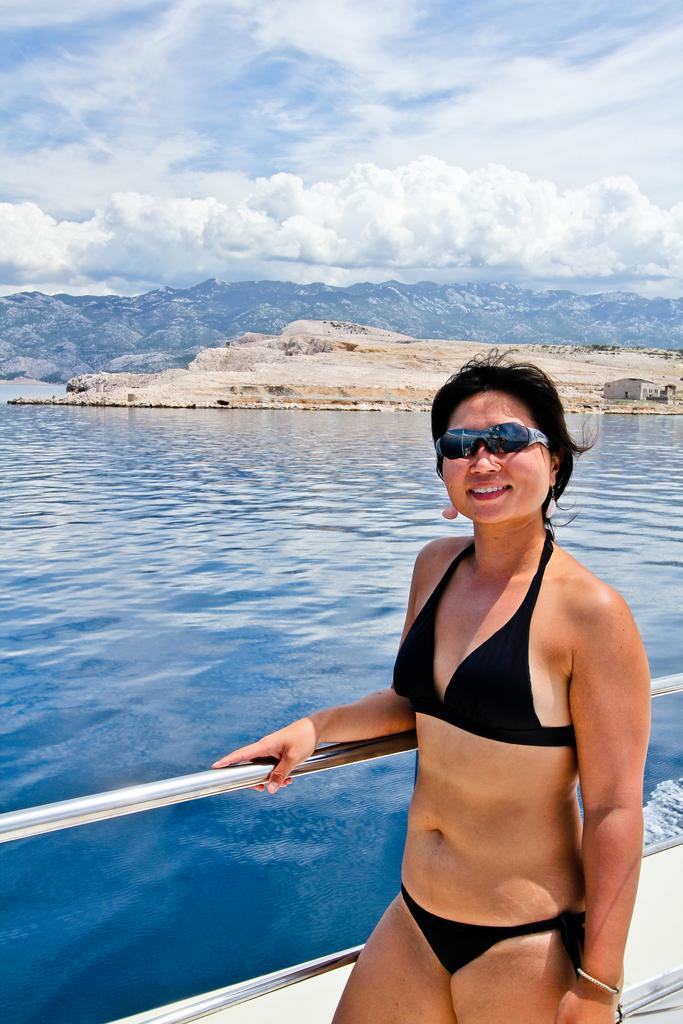Who is present in the image? There is a girl standing in the image. What object can be seen in the image? There is a steel rod in the image. What can be seen in the background of the image? There is water, a mountain, and a cloudy sky visible in the background. What type of beast can be seen flying in the image? There is no beast present in the image, and no creatures are depicted as flying. 